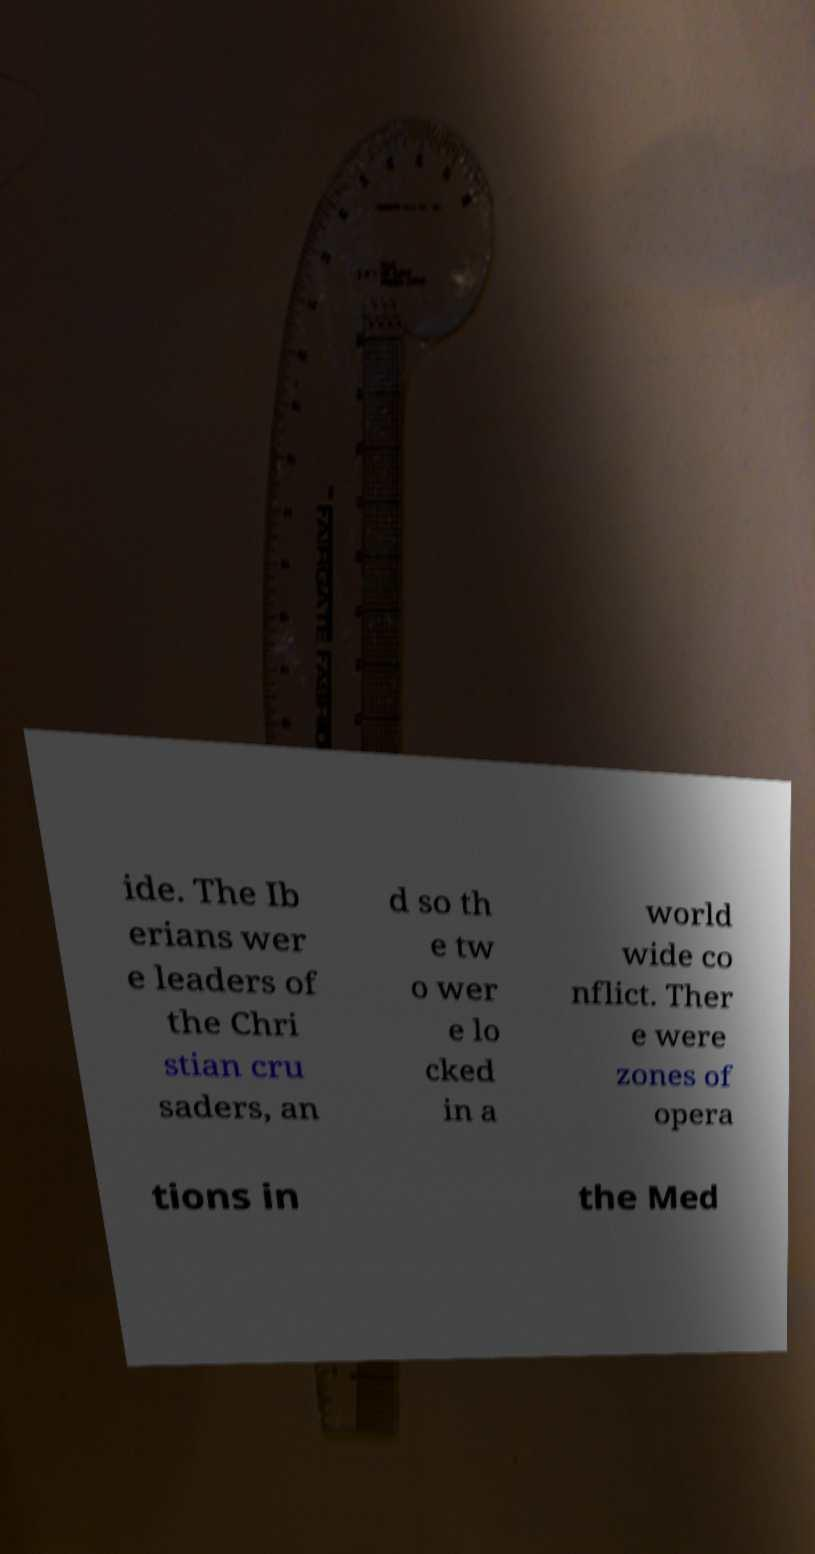What messages or text are displayed in this image? I need them in a readable, typed format. ide. The Ib erians wer e leaders of the Chri stian cru saders, an d so th e tw o wer e lo cked in a world wide co nflict. Ther e were zones of opera tions in the Med 